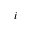Convert formula to latex. <formula><loc_0><loc_0><loc_500><loc_500>i</formula> 